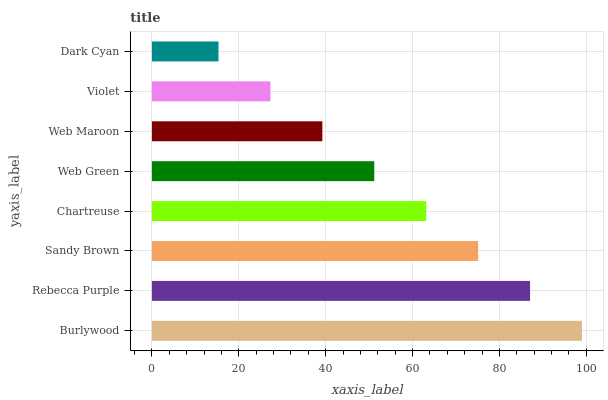Is Dark Cyan the minimum?
Answer yes or no. Yes. Is Burlywood the maximum?
Answer yes or no. Yes. Is Rebecca Purple the minimum?
Answer yes or no. No. Is Rebecca Purple the maximum?
Answer yes or no. No. Is Burlywood greater than Rebecca Purple?
Answer yes or no. Yes. Is Rebecca Purple less than Burlywood?
Answer yes or no. Yes. Is Rebecca Purple greater than Burlywood?
Answer yes or no. No. Is Burlywood less than Rebecca Purple?
Answer yes or no. No. Is Chartreuse the high median?
Answer yes or no. Yes. Is Web Green the low median?
Answer yes or no. Yes. Is Web Maroon the high median?
Answer yes or no. No. Is Rebecca Purple the low median?
Answer yes or no. No. 